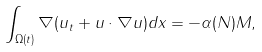<formula> <loc_0><loc_0><loc_500><loc_500>\int _ { \Omega ( t ) } \nabla ( u _ { t } + u \cdot \nabla u ) d x = - \alpha ( N ) M ,</formula> 